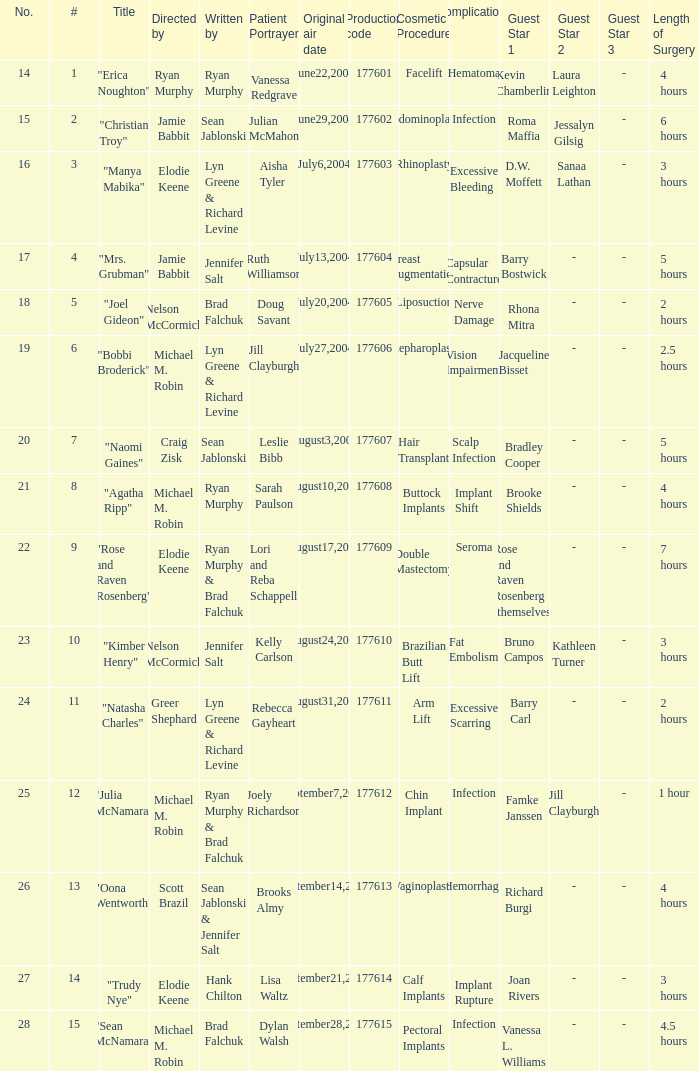Who wrote episode number 28? Brad Falchuk. 